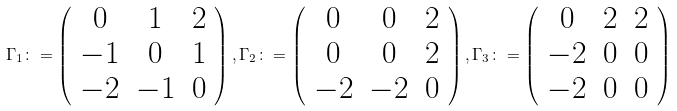<formula> <loc_0><loc_0><loc_500><loc_500>\Gamma _ { 1 } \colon = \left ( \begin{array} { c c c } 0 & 1 & 2 \\ - 1 & 0 & 1 \\ - 2 & - 1 & 0 \end{array} \right ) , \Gamma _ { 2 } \colon = \left ( \begin{array} { c c c } 0 & 0 & 2 \\ 0 & 0 & 2 \\ - 2 & - 2 & 0 \end{array} \right ) , \Gamma _ { 3 } \colon = \left ( \begin{array} { c c c } 0 & 2 & 2 \\ - 2 & 0 & 0 \\ - 2 & 0 & 0 \end{array} \right )</formula> 